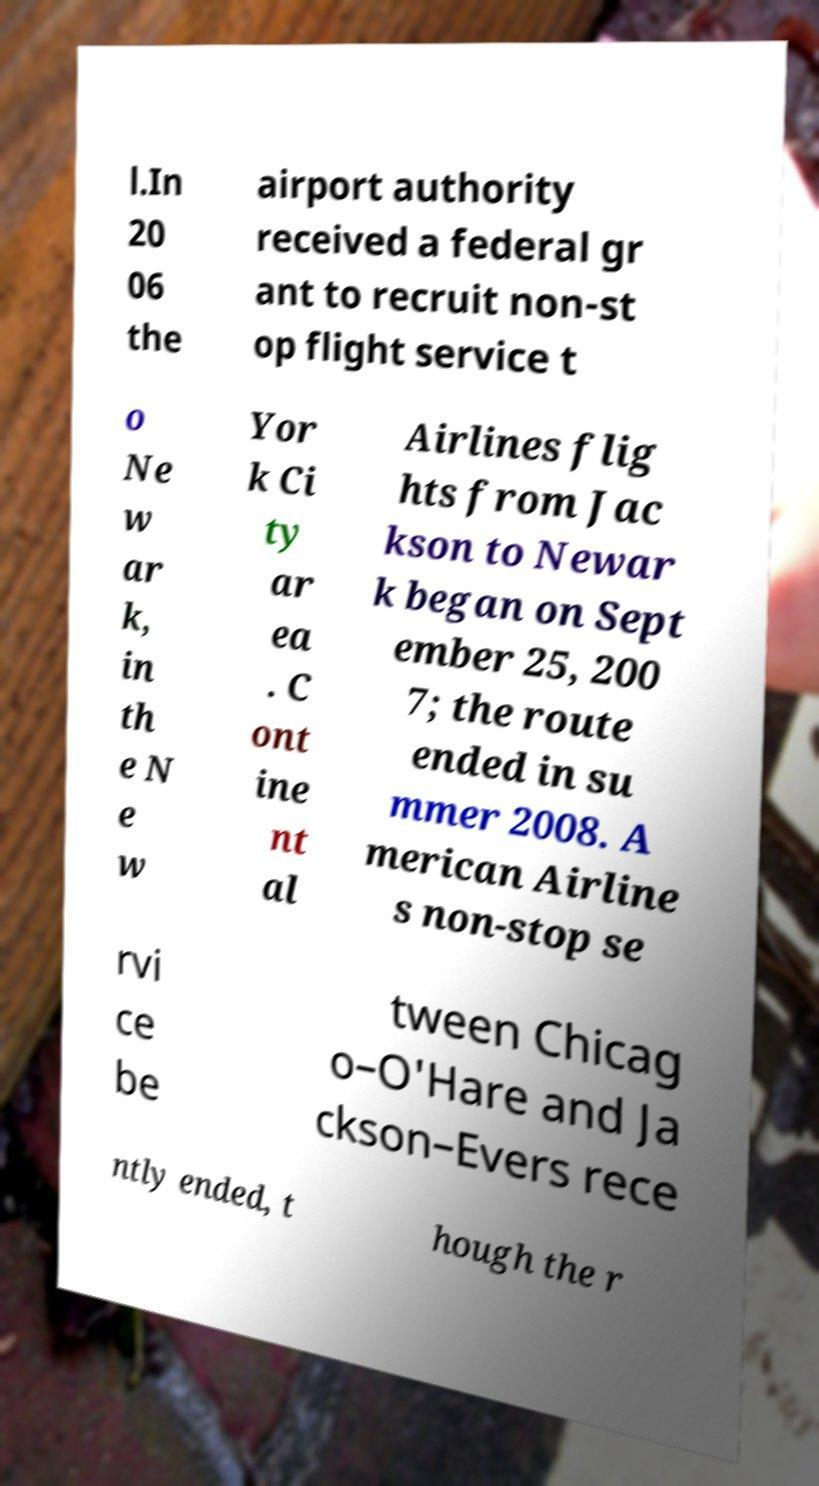What messages or text are displayed in this image? I need them in a readable, typed format. l.In 20 06 the airport authority received a federal gr ant to recruit non-st op flight service t o Ne w ar k, in th e N e w Yor k Ci ty ar ea . C ont ine nt al Airlines flig hts from Jac kson to Newar k began on Sept ember 25, 200 7; the route ended in su mmer 2008. A merican Airline s non-stop se rvi ce be tween Chicag o–O'Hare and Ja ckson–Evers rece ntly ended, t hough the r 